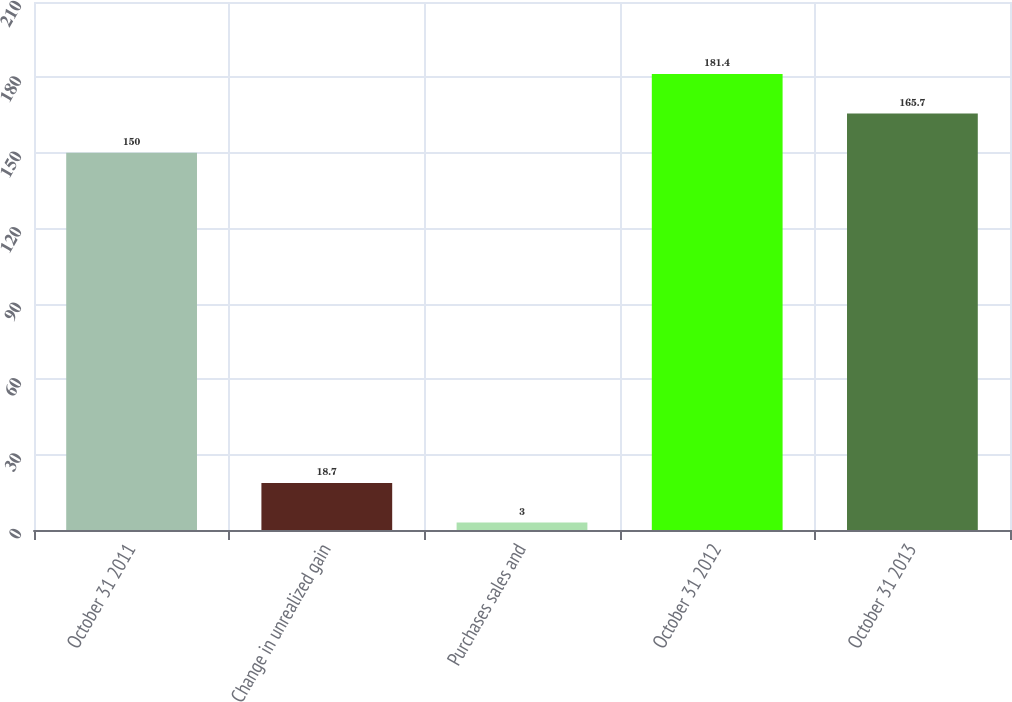Convert chart. <chart><loc_0><loc_0><loc_500><loc_500><bar_chart><fcel>October 31 2011<fcel>Change in unrealized gain<fcel>Purchases sales and<fcel>October 31 2012<fcel>October 31 2013<nl><fcel>150<fcel>18.7<fcel>3<fcel>181.4<fcel>165.7<nl></chart> 